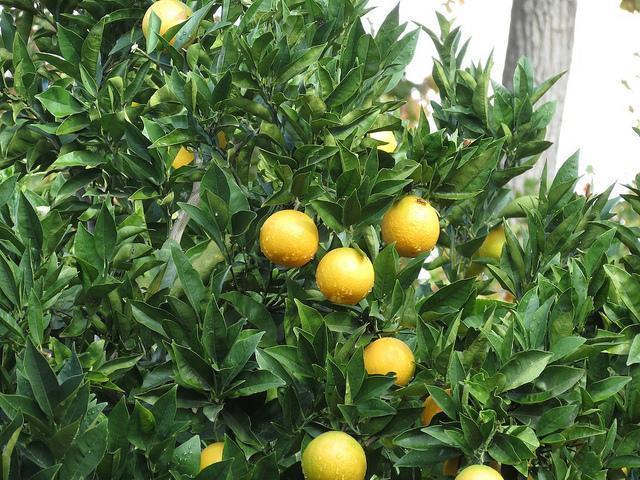How many oranges are in the photo?
Give a very brief answer. 5. 